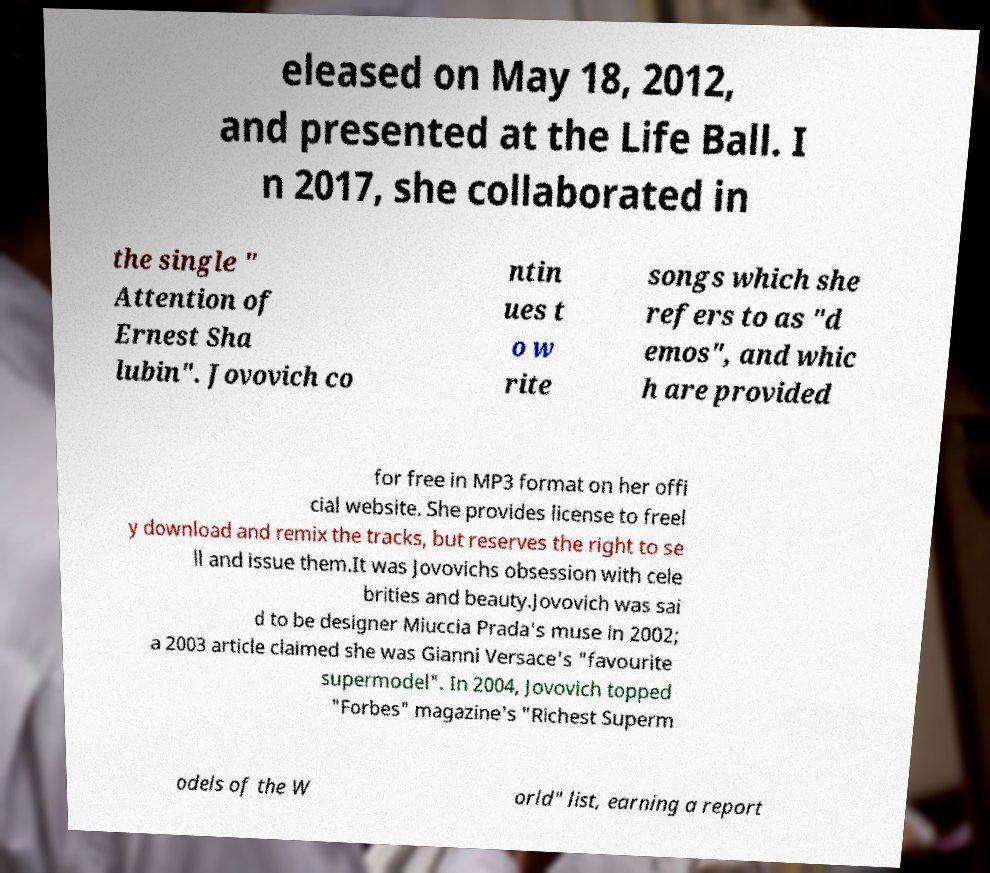Please identify and transcribe the text found in this image. eleased on May 18, 2012, and presented at the Life Ball. I n 2017, she collaborated in the single " Attention of Ernest Sha lubin". Jovovich co ntin ues t o w rite songs which she refers to as "d emos", and whic h are provided for free in MP3 format on her offi cial website. She provides license to freel y download and remix the tracks, but reserves the right to se ll and issue them.It was Jovovichs obsession with cele brities and beauty.Jovovich was sai d to be designer Miuccia Prada's muse in 2002; a 2003 article claimed she was Gianni Versace's "favourite supermodel". In 2004, Jovovich topped "Forbes" magazine's "Richest Superm odels of the W orld" list, earning a report 